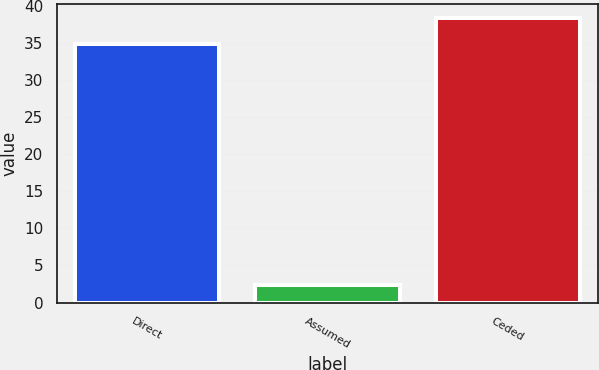<chart> <loc_0><loc_0><loc_500><loc_500><bar_chart><fcel>Direct<fcel>Assumed<fcel>Ceded<nl><fcel>34.9<fcel>2.3<fcel>38.39<nl></chart> 